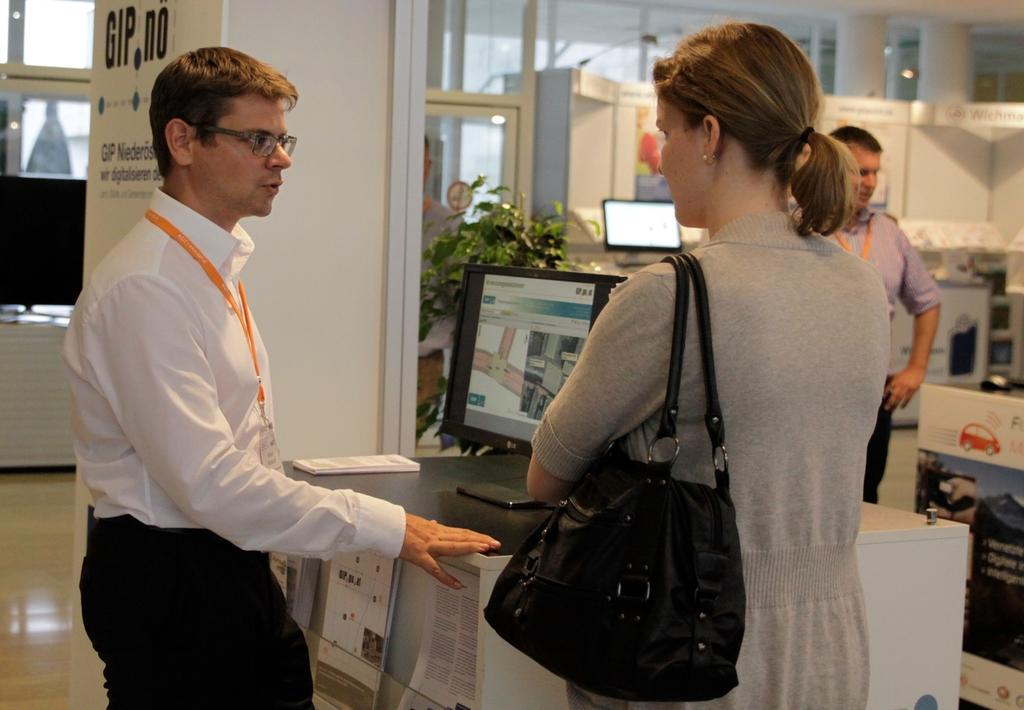How many people are in the image? There are two men and a woman in the image. What is the woman wearing? The woman is wearing a handbag. What is in front of the woman? There is a desk top in front of the woman. What can be seen in the background of the image? There is a plant, a pillar, and a glass door in the background of the image. Can you see any dinosaurs in the image? No, there are no dinosaurs present in the image. What type of horn is visible on the woman's head in the image? There is no horn visible on the woman's head in the image. 